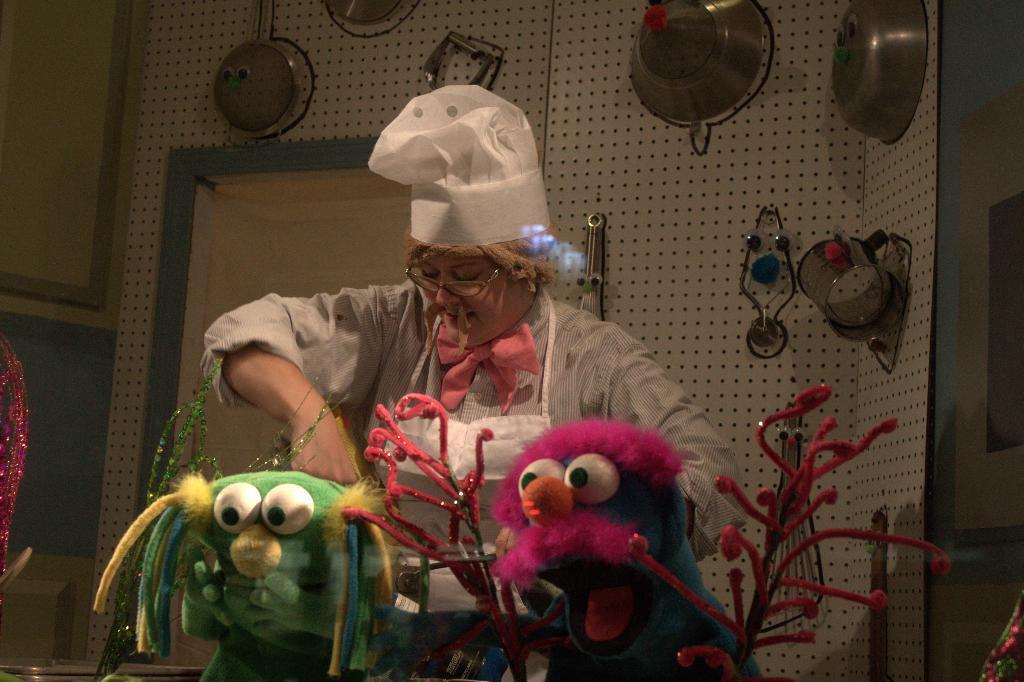Can you describe this image briefly? In this image I can see the person wearing the ash color dress and the white color apron and also hat. In-front of the person I can see two toys which are in different colors. In the back there are many utensils to the wall. 